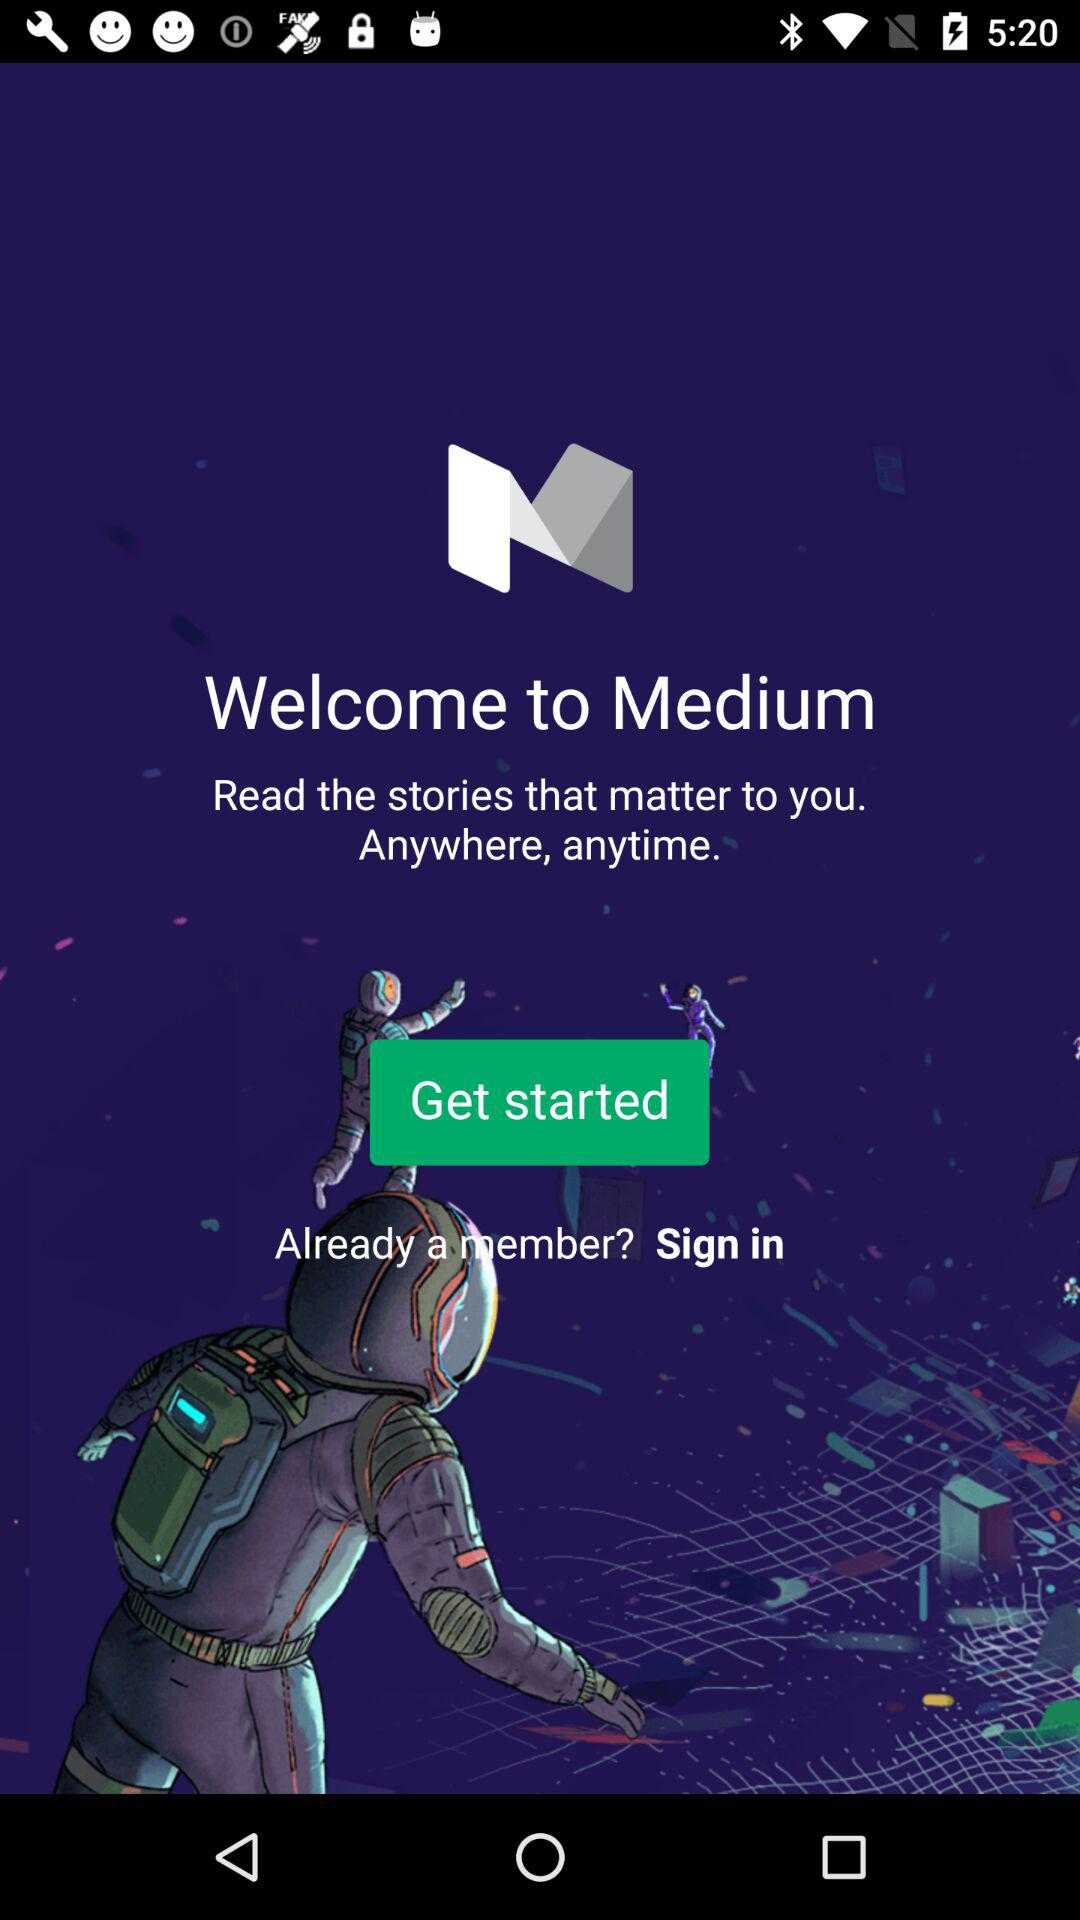What is the name of the application? The name of the application is "Medium". 